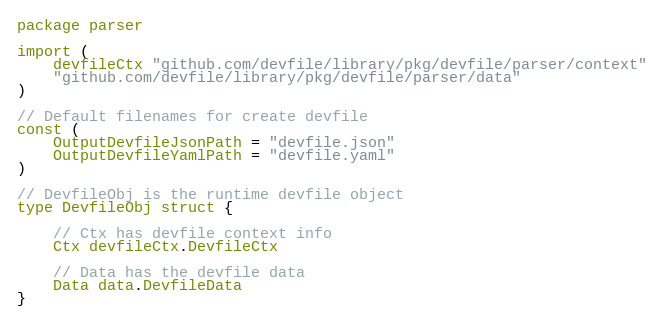Convert code to text. <code><loc_0><loc_0><loc_500><loc_500><_Go_>package parser

import (
	devfileCtx "github.com/devfile/library/pkg/devfile/parser/context"
	"github.com/devfile/library/pkg/devfile/parser/data"
)

// Default filenames for create devfile
const (
	OutputDevfileJsonPath = "devfile.json"
	OutputDevfileYamlPath = "devfile.yaml"
)

// DevfileObj is the runtime devfile object
type DevfileObj struct {

	// Ctx has devfile context info
	Ctx devfileCtx.DevfileCtx

	// Data has the devfile data
	Data data.DevfileData
}
</code> 